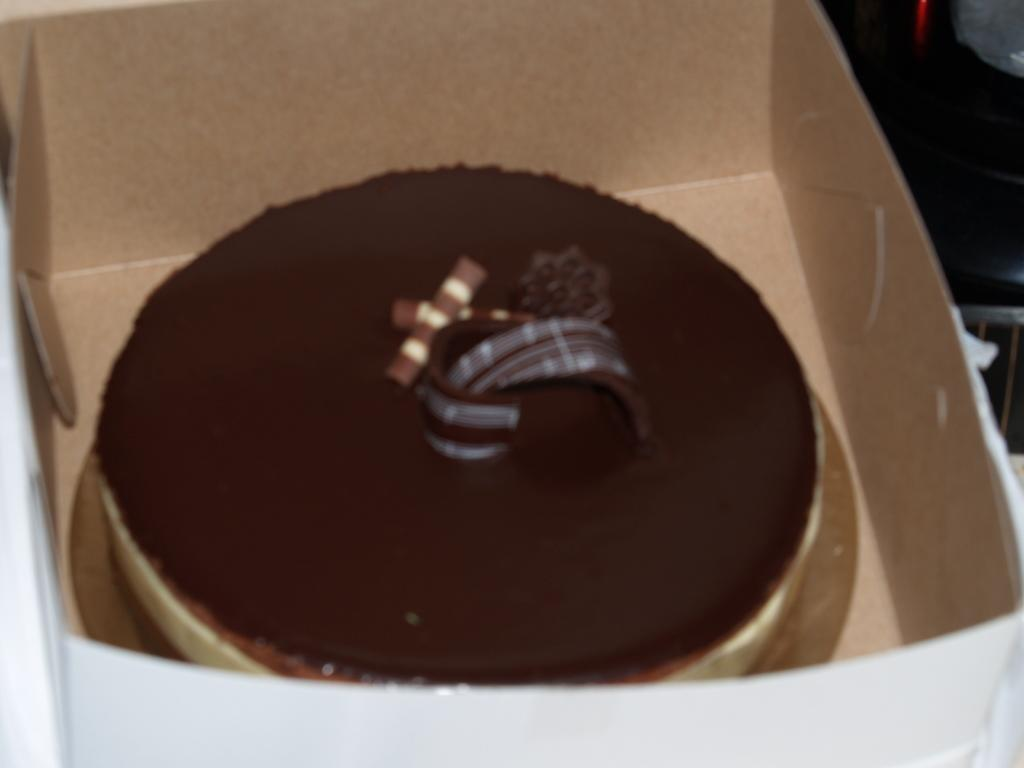What is the main subject in the foreground of the image? There is a cake in a cardboard box in the foreground of the image. Can you describe the objects on the top right of the image? Unfortunately, the objects on the top right of the image are not visible, so we cannot describe them. How many snails can be seen crawling on the cake in the image? There are no snails visible on the cake in the image. What type of butter is used to decorate the cake in the image? There is no butter visible on the cake in the image. 